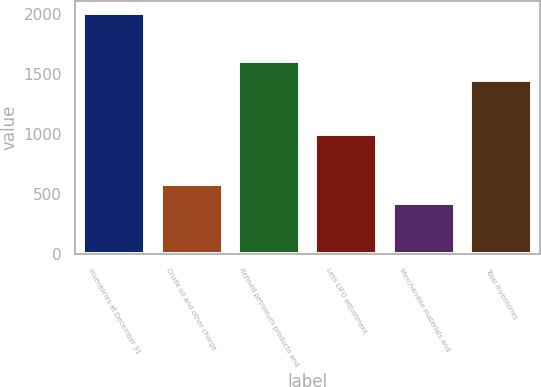<chart> <loc_0><loc_0><loc_500><loc_500><bar_chart><fcel>Inventories at December 31<fcel>Crude oil and other charge<fcel>Refined petroleum products and<fcel>Less LIFO adjustment<fcel>Merchandise materials and<fcel>Total inventories<nl><fcel>2010<fcel>581.7<fcel>1610.7<fcel>995<fcel>423<fcel>1452<nl></chart> 